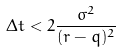Convert formula to latex. <formula><loc_0><loc_0><loc_500><loc_500>\Delta t < 2 \frac { \sigma ^ { 2 } } { ( r - q ) ^ { 2 } }</formula> 